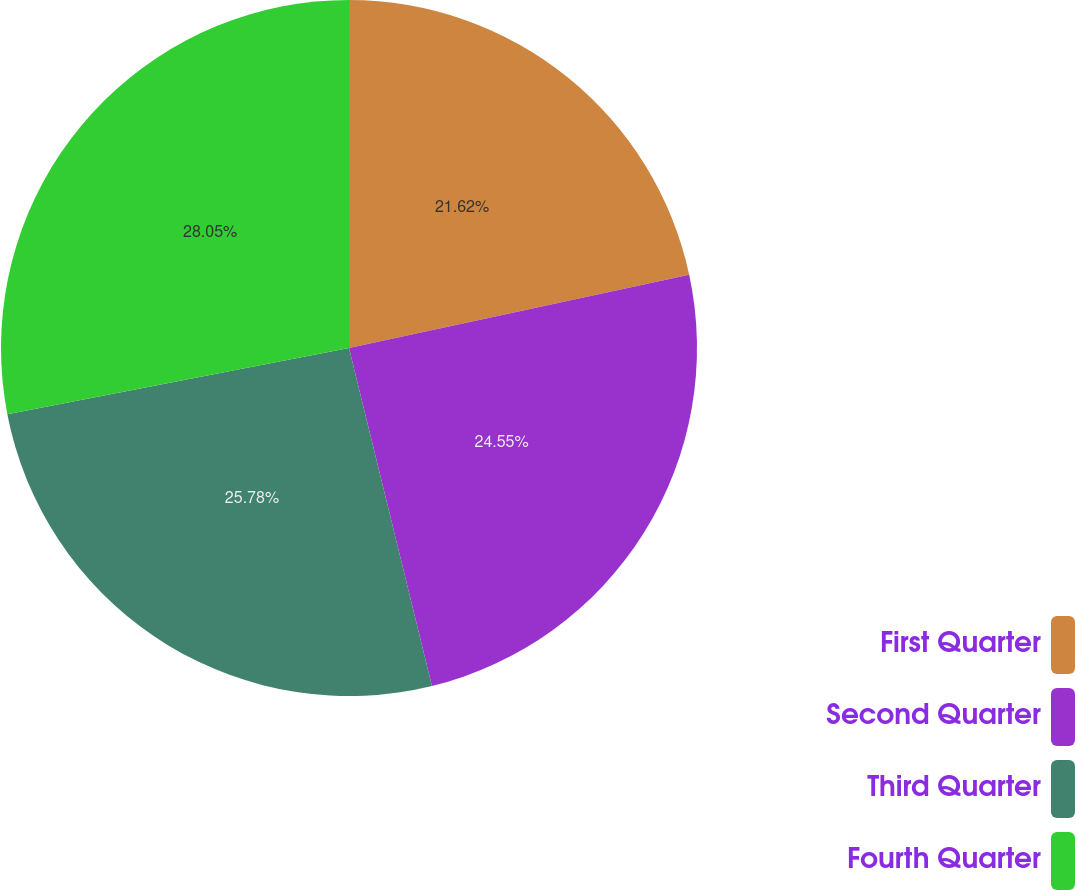<chart> <loc_0><loc_0><loc_500><loc_500><pie_chart><fcel>First Quarter<fcel>Second Quarter<fcel>Third Quarter<fcel>Fourth Quarter<nl><fcel>21.62%<fcel>24.55%<fcel>25.78%<fcel>28.05%<nl></chart> 